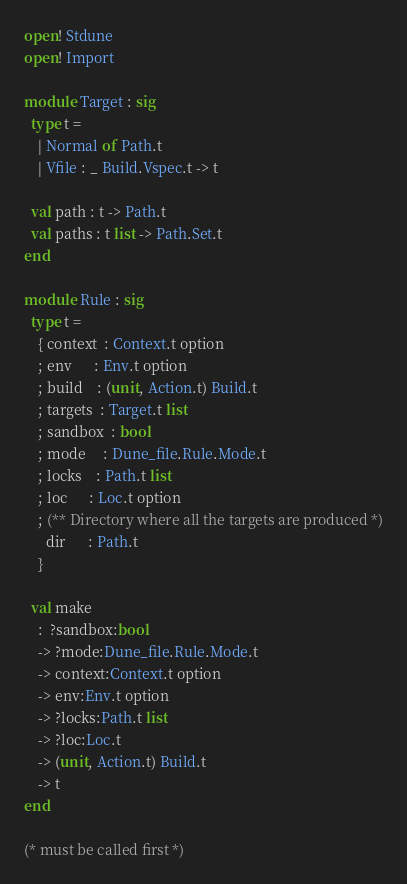Convert code to text. <code><loc_0><loc_0><loc_500><loc_500><_OCaml_>open! Stdune
open! Import

module Target : sig
  type t =
    | Normal of Path.t
    | Vfile : _ Build.Vspec.t -> t

  val path : t -> Path.t
  val paths : t list -> Path.Set.t
end

module Rule : sig
  type t =
    { context  : Context.t option
    ; env      : Env.t option
    ; build    : (unit, Action.t) Build.t
    ; targets  : Target.t list
    ; sandbox  : bool
    ; mode     : Dune_file.Rule.Mode.t
    ; locks    : Path.t list
    ; loc      : Loc.t option
    ; (** Directory where all the targets are produced *)
      dir      : Path.t
    }

  val make
    :  ?sandbox:bool
    -> ?mode:Dune_file.Rule.Mode.t
    -> context:Context.t option
    -> env:Env.t option
    -> ?locks:Path.t list
    -> ?loc:Loc.t
    -> (unit, Action.t) Build.t
    -> t
end

(* must be called first *)</code> 